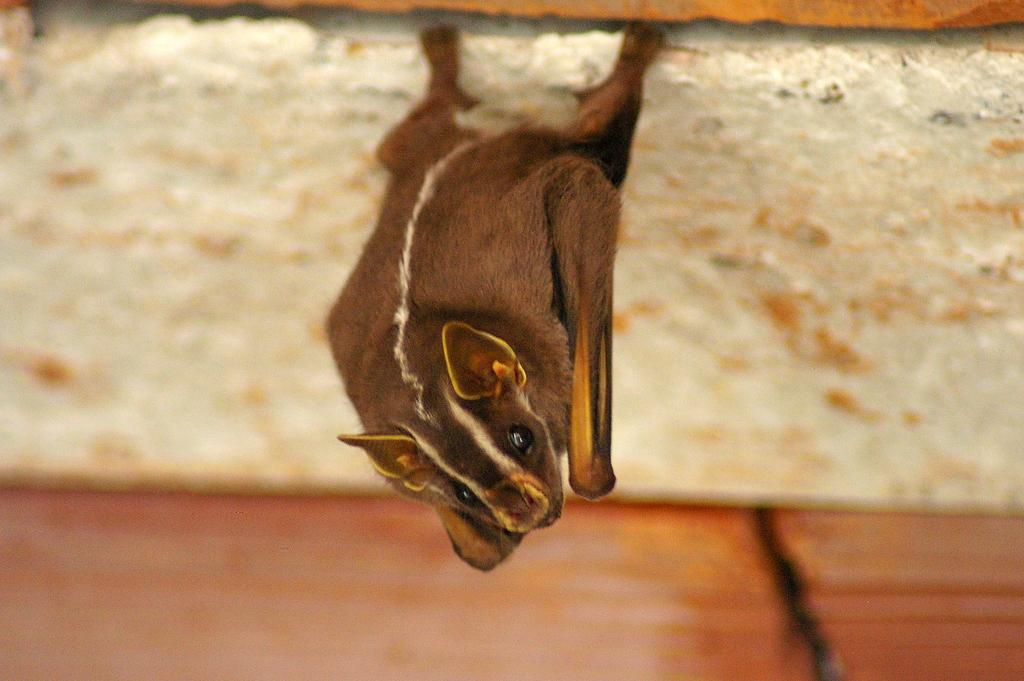What animal is on the platform in the image? There is a bat on a platform in the image. Can you describe the object at the bottom of the image? Unfortunately, the facts provided do not give any information about the object at the bottom of the image. How many tomatoes are hanging from the cord in the image? There is no mention of tomatoes or a cord in the image, so it is not possible to answer this question. 